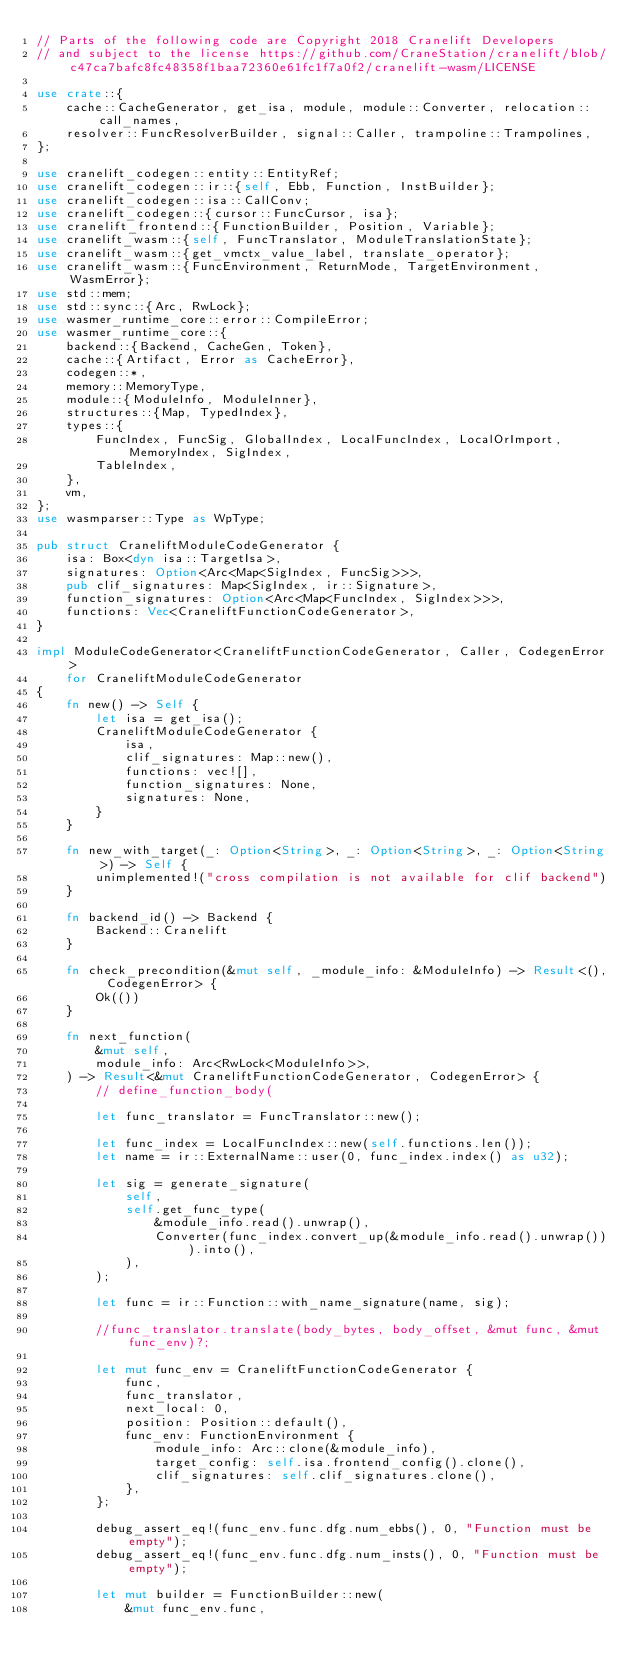<code> <loc_0><loc_0><loc_500><loc_500><_Rust_>// Parts of the following code are Copyright 2018 Cranelift Developers
// and subject to the license https://github.com/CraneStation/cranelift/blob/c47ca7bafc8fc48358f1baa72360e61fc1f7a0f2/cranelift-wasm/LICENSE

use crate::{
    cache::CacheGenerator, get_isa, module, module::Converter, relocation::call_names,
    resolver::FuncResolverBuilder, signal::Caller, trampoline::Trampolines,
};

use cranelift_codegen::entity::EntityRef;
use cranelift_codegen::ir::{self, Ebb, Function, InstBuilder};
use cranelift_codegen::isa::CallConv;
use cranelift_codegen::{cursor::FuncCursor, isa};
use cranelift_frontend::{FunctionBuilder, Position, Variable};
use cranelift_wasm::{self, FuncTranslator, ModuleTranslationState};
use cranelift_wasm::{get_vmctx_value_label, translate_operator};
use cranelift_wasm::{FuncEnvironment, ReturnMode, TargetEnvironment, WasmError};
use std::mem;
use std::sync::{Arc, RwLock};
use wasmer_runtime_core::error::CompileError;
use wasmer_runtime_core::{
    backend::{Backend, CacheGen, Token},
    cache::{Artifact, Error as CacheError},
    codegen::*,
    memory::MemoryType,
    module::{ModuleInfo, ModuleInner},
    structures::{Map, TypedIndex},
    types::{
        FuncIndex, FuncSig, GlobalIndex, LocalFuncIndex, LocalOrImport, MemoryIndex, SigIndex,
        TableIndex,
    },
    vm,
};
use wasmparser::Type as WpType;

pub struct CraneliftModuleCodeGenerator {
    isa: Box<dyn isa::TargetIsa>,
    signatures: Option<Arc<Map<SigIndex, FuncSig>>>,
    pub clif_signatures: Map<SigIndex, ir::Signature>,
    function_signatures: Option<Arc<Map<FuncIndex, SigIndex>>>,
    functions: Vec<CraneliftFunctionCodeGenerator>,
}

impl ModuleCodeGenerator<CraneliftFunctionCodeGenerator, Caller, CodegenError>
    for CraneliftModuleCodeGenerator
{
    fn new() -> Self {
        let isa = get_isa();
        CraneliftModuleCodeGenerator {
            isa,
            clif_signatures: Map::new(),
            functions: vec![],
            function_signatures: None,
            signatures: None,
        }
    }

    fn new_with_target(_: Option<String>, _: Option<String>, _: Option<String>) -> Self {
        unimplemented!("cross compilation is not available for clif backend")
    }

    fn backend_id() -> Backend {
        Backend::Cranelift
    }

    fn check_precondition(&mut self, _module_info: &ModuleInfo) -> Result<(), CodegenError> {
        Ok(())
    }

    fn next_function(
        &mut self,
        module_info: Arc<RwLock<ModuleInfo>>,
    ) -> Result<&mut CraneliftFunctionCodeGenerator, CodegenError> {
        // define_function_body(

        let func_translator = FuncTranslator::new();

        let func_index = LocalFuncIndex::new(self.functions.len());
        let name = ir::ExternalName::user(0, func_index.index() as u32);

        let sig = generate_signature(
            self,
            self.get_func_type(
                &module_info.read().unwrap(),
                Converter(func_index.convert_up(&module_info.read().unwrap())).into(),
            ),
        );

        let func = ir::Function::with_name_signature(name, sig);

        //func_translator.translate(body_bytes, body_offset, &mut func, &mut func_env)?;

        let mut func_env = CraneliftFunctionCodeGenerator {
            func,
            func_translator,
            next_local: 0,
            position: Position::default(),
            func_env: FunctionEnvironment {
                module_info: Arc::clone(&module_info),
                target_config: self.isa.frontend_config().clone(),
                clif_signatures: self.clif_signatures.clone(),
            },
        };

        debug_assert_eq!(func_env.func.dfg.num_ebbs(), 0, "Function must be empty");
        debug_assert_eq!(func_env.func.dfg.num_insts(), 0, "Function must be empty");

        let mut builder = FunctionBuilder::new(
            &mut func_env.func,</code> 